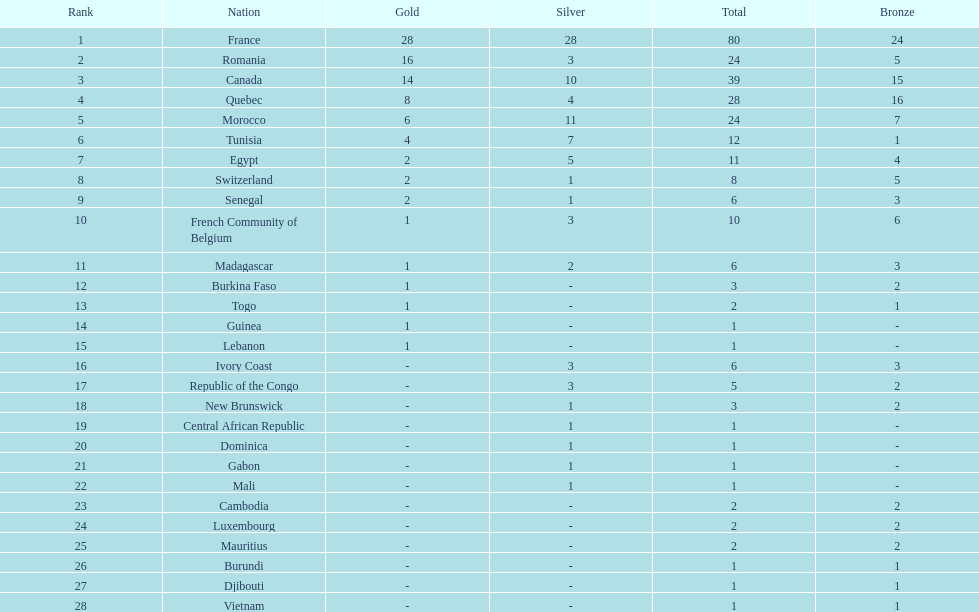What is the difference between france's and egypt's silver medals? 23. Could you parse the entire table as a dict? {'header': ['Rank', 'Nation', 'Gold', 'Silver', 'Total', 'Bronze'], 'rows': [['1', 'France', '28', '28', '80', '24'], ['2', 'Romania', '16', '3', '24', '5'], ['3', 'Canada', '14', '10', '39', '15'], ['4', 'Quebec', '8', '4', '28', '16'], ['5', 'Morocco', '6', '11', '24', '7'], ['6', 'Tunisia', '4', '7', '12', '1'], ['7', 'Egypt', '2', '5', '11', '4'], ['8', 'Switzerland', '2', '1', '8', '5'], ['9', 'Senegal', '2', '1', '6', '3'], ['10', 'French Community of Belgium', '1', '3', '10', '6'], ['11', 'Madagascar', '1', '2', '6', '3'], ['12', 'Burkina Faso', '1', '-', '3', '2'], ['13', 'Togo', '1', '-', '2', '1'], ['14', 'Guinea', '1', '-', '1', '-'], ['15', 'Lebanon', '1', '-', '1', '-'], ['16', 'Ivory Coast', '-', '3', '6', '3'], ['17', 'Republic of the Congo', '-', '3', '5', '2'], ['18', 'New Brunswick', '-', '1', '3', '2'], ['19', 'Central African Republic', '-', '1', '1', '-'], ['20', 'Dominica', '-', '1', '1', '-'], ['21', 'Gabon', '-', '1', '1', '-'], ['22', 'Mali', '-', '1', '1', '-'], ['23', 'Cambodia', '-', '-', '2', '2'], ['24', 'Luxembourg', '-', '-', '2', '2'], ['25', 'Mauritius', '-', '-', '2', '2'], ['26', 'Burundi', '-', '-', '1', '1'], ['27', 'Djibouti', '-', '-', '1', '1'], ['28', 'Vietnam', '-', '-', '1', '1']]} 